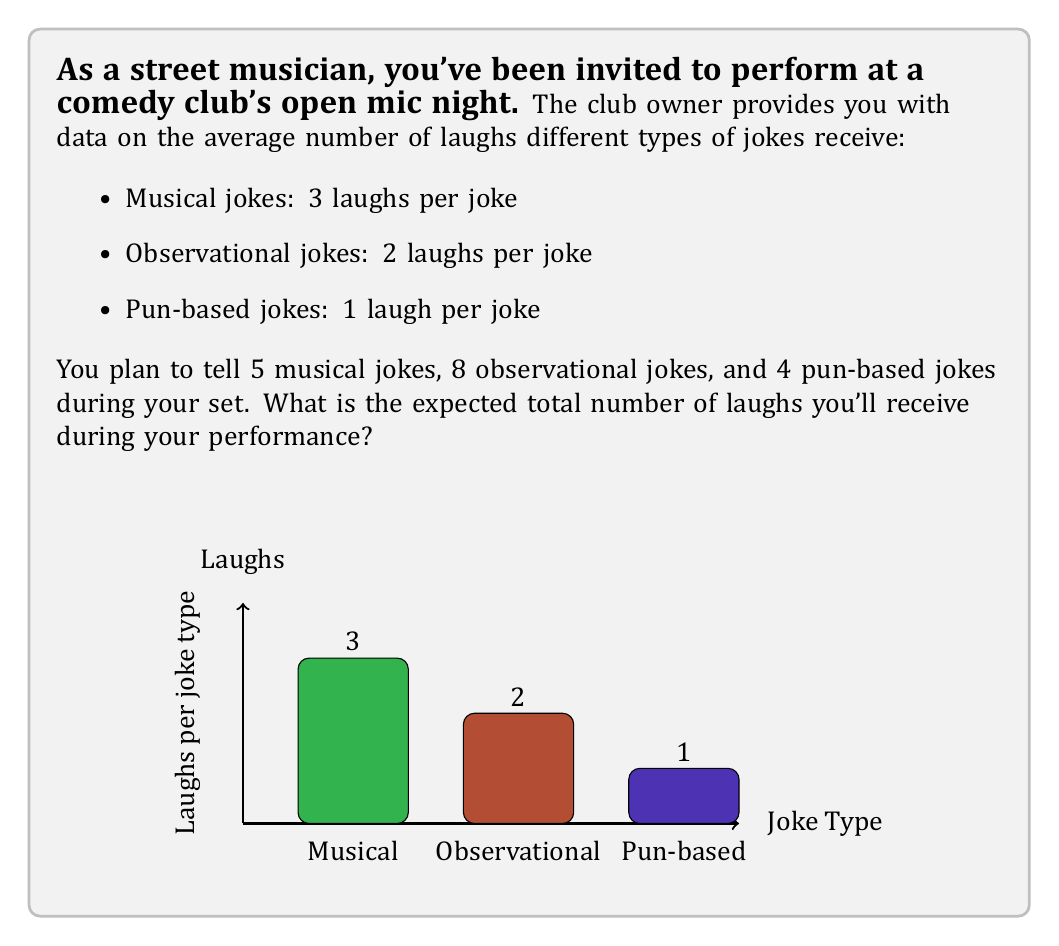Can you answer this question? To solve this problem, we'll use the concept of expected value. The expected value is calculated by multiplying each possible outcome by its probability and then summing these products.

In this case, we know the exact number of jokes for each type and the average number of laughs they receive. So, we can simply multiply these numbers and sum the results:

1. For musical jokes:
   $5 \text{ jokes} \times 3 \text{ laughs per joke} = 15 \text{ laughs}$

2. For observational jokes:
   $8 \text{ jokes} \times 2 \text{ laughs per joke} = 16 \text{ laughs}$

3. For pun-based jokes:
   $4 \text{ jokes} \times 1 \text{ laugh per joke} = 4 \text{ laughs}$

Now, we sum these expected values:

$$ \text{Total expected laughs} = 15 + 16 + 4 = 35 $$

Therefore, the expected total number of laughs during your performance is 35.
Answer: 35 laughs 